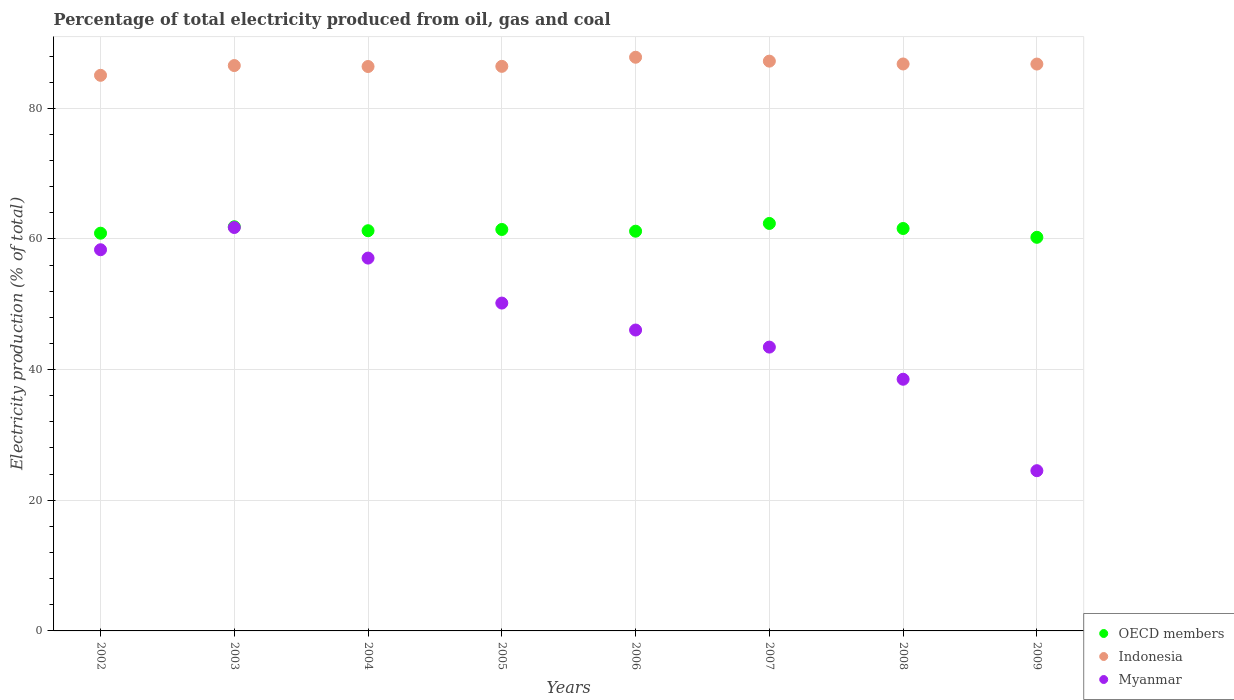Is the number of dotlines equal to the number of legend labels?
Offer a terse response. Yes. What is the electricity production in in OECD members in 2004?
Provide a short and direct response. 61.26. Across all years, what is the maximum electricity production in in Indonesia?
Keep it short and to the point. 87.81. Across all years, what is the minimum electricity production in in OECD members?
Make the answer very short. 60.25. In which year was the electricity production in in OECD members maximum?
Offer a very short reply. 2007. In which year was the electricity production in in Myanmar minimum?
Offer a terse response. 2009. What is the total electricity production in in Indonesia in the graph?
Offer a very short reply. 692.97. What is the difference between the electricity production in in Myanmar in 2004 and that in 2005?
Provide a short and direct response. 6.89. What is the difference between the electricity production in in Myanmar in 2004 and the electricity production in in Indonesia in 2007?
Your answer should be very brief. -30.15. What is the average electricity production in in OECD members per year?
Keep it short and to the point. 61.36. In the year 2009, what is the difference between the electricity production in in OECD members and electricity production in in Indonesia?
Give a very brief answer. -26.52. In how many years, is the electricity production in in Myanmar greater than 12 %?
Your response must be concise. 8. What is the ratio of the electricity production in in Indonesia in 2003 to that in 2008?
Provide a succinct answer. 1. Is the difference between the electricity production in in OECD members in 2005 and 2006 greater than the difference between the electricity production in in Indonesia in 2005 and 2006?
Offer a terse response. Yes. What is the difference between the highest and the second highest electricity production in in Myanmar?
Offer a very short reply. 3.4. What is the difference between the highest and the lowest electricity production in in Indonesia?
Offer a terse response. 2.76. Is it the case that in every year, the sum of the electricity production in in Indonesia and electricity production in in Myanmar  is greater than the electricity production in in OECD members?
Provide a short and direct response. Yes. Does the electricity production in in OECD members monotonically increase over the years?
Ensure brevity in your answer.  No. Is the electricity production in in Myanmar strictly greater than the electricity production in in Indonesia over the years?
Provide a succinct answer. No. How many dotlines are there?
Keep it short and to the point. 3. Does the graph contain grids?
Your answer should be compact. Yes. Where does the legend appear in the graph?
Provide a succinct answer. Bottom right. What is the title of the graph?
Your response must be concise. Percentage of total electricity produced from oil, gas and coal. Does "Burundi" appear as one of the legend labels in the graph?
Make the answer very short. No. What is the label or title of the X-axis?
Offer a terse response. Years. What is the label or title of the Y-axis?
Offer a terse response. Electricity production (% of total). What is the Electricity production (% of total) of OECD members in 2002?
Keep it short and to the point. 60.88. What is the Electricity production (% of total) in Indonesia in 2002?
Make the answer very short. 85.05. What is the Electricity production (% of total) of Myanmar in 2002?
Your answer should be very brief. 58.35. What is the Electricity production (% of total) in OECD members in 2003?
Offer a very short reply. 61.86. What is the Electricity production (% of total) in Indonesia in 2003?
Your answer should be very brief. 86.54. What is the Electricity production (% of total) of Myanmar in 2003?
Your response must be concise. 61.75. What is the Electricity production (% of total) of OECD members in 2004?
Give a very brief answer. 61.26. What is the Electricity production (% of total) in Indonesia in 2004?
Give a very brief answer. 86.39. What is the Electricity production (% of total) of Myanmar in 2004?
Make the answer very short. 57.07. What is the Electricity production (% of total) in OECD members in 2005?
Your answer should be very brief. 61.45. What is the Electricity production (% of total) of Indonesia in 2005?
Give a very brief answer. 86.42. What is the Electricity production (% of total) of Myanmar in 2005?
Your response must be concise. 50.18. What is the Electricity production (% of total) of OECD members in 2006?
Your response must be concise. 61.19. What is the Electricity production (% of total) of Indonesia in 2006?
Your answer should be very brief. 87.81. What is the Electricity production (% of total) in Myanmar in 2006?
Give a very brief answer. 46.06. What is the Electricity production (% of total) of OECD members in 2007?
Ensure brevity in your answer.  62.37. What is the Electricity production (% of total) in Indonesia in 2007?
Make the answer very short. 87.22. What is the Electricity production (% of total) of Myanmar in 2007?
Give a very brief answer. 43.44. What is the Electricity production (% of total) in OECD members in 2008?
Your answer should be very brief. 61.6. What is the Electricity production (% of total) of Indonesia in 2008?
Provide a succinct answer. 86.78. What is the Electricity production (% of total) in Myanmar in 2008?
Offer a very short reply. 38.52. What is the Electricity production (% of total) of OECD members in 2009?
Offer a terse response. 60.25. What is the Electricity production (% of total) in Indonesia in 2009?
Provide a short and direct response. 86.77. What is the Electricity production (% of total) in Myanmar in 2009?
Your response must be concise. 24.53. Across all years, what is the maximum Electricity production (% of total) of OECD members?
Provide a short and direct response. 62.37. Across all years, what is the maximum Electricity production (% of total) in Indonesia?
Provide a succinct answer. 87.81. Across all years, what is the maximum Electricity production (% of total) of Myanmar?
Offer a terse response. 61.75. Across all years, what is the minimum Electricity production (% of total) of OECD members?
Your answer should be very brief. 60.25. Across all years, what is the minimum Electricity production (% of total) of Indonesia?
Provide a short and direct response. 85.05. Across all years, what is the minimum Electricity production (% of total) of Myanmar?
Give a very brief answer. 24.53. What is the total Electricity production (% of total) of OECD members in the graph?
Make the answer very short. 490.85. What is the total Electricity production (% of total) of Indonesia in the graph?
Offer a very short reply. 692.97. What is the total Electricity production (% of total) of Myanmar in the graph?
Your response must be concise. 379.9. What is the difference between the Electricity production (% of total) in OECD members in 2002 and that in 2003?
Your response must be concise. -0.98. What is the difference between the Electricity production (% of total) of Indonesia in 2002 and that in 2003?
Your response must be concise. -1.49. What is the difference between the Electricity production (% of total) in Myanmar in 2002 and that in 2003?
Make the answer very short. -3.4. What is the difference between the Electricity production (% of total) in OECD members in 2002 and that in 2004?
Provide a short and direct response. -0.38. What is the difference between the Electricity production (% of total) in Indonesia in 2002 and that in 2004?
Your response must be concise. -1.35. What is the difference between the Electricity production (% of total) of Myanmar in 2002 and that in 2004?
Your answer should be very brief. 1.28. What is the difference between the Electricity production (% of total) of OECD members in 2002 and that in 2005?
Your response must be concise. -0.57. What is the difference between the Electricity production (% of total) of Indonesia in 2002 and that in 2005?
Provide a short and direct response. -1.37. What is the difference between the Electricity production (% of total) in Myanmar in 2002 and that in 2005?
Ensure brevity in your answer.  8.16. What is the difference between the Electricity production (% of total) of OECD members in 2002 and that in 2006?
Offer a very short reply. -0.31. What is the difference between the Electricity production (% of total) of Indonesia in 2002 and that in 2006?
Give a very brief answer. -2.76. What is the difference between the Electricity production (% of total) of Myanmar in 2002 and that in 2006?
Give a very brief answer. 12.29. What is the difference between the Electricity production (% of total) in OECD members in 2002 and that in 2007?
Offer a terse response. -1.49. What is the difference between the Electricity production (% of total) of Indonesia in 2002 and that in 2007?
Your answer should be compact. -2.17. What is the difference between the Electricity production (% of total) in Myanmar in 2002 and that in 2007?
Your response must be concise. 14.9. What is the difference between the Electricity production (% of total) of OECD members in 2002 and that in 2008?
Provide a short and direct response. -0.72. What is the difference between the Electricity production (% of total) of Indonesia in 2002 and that in 2008?
Offer a terse response. -1.73. What is the difference between the Electricity production (% of total) in Myanmar in 2002 and that in 2008?
Provide a short and direct response. 19.82. What is the difference between the Electricity production (% of total) of OECD members in 2002 and that in 2009?
Make the answer very short. 0.63. What is the difference between the Electricity production (% of total) in Indonesia in 2002 and that in 2009?
Ensure brevity in your answer.  -1.72. What is the difference between the Electricity production (% of total) in Myanmar in 2002 and that in 2009?
Make the answer very short. 33.82. What is the difference between the Electricity production (% of total) in OECD members in 2003 and that in 2004?
Offer a terse response. 0.61. What is the difference between the Electricity production (% of total) of Indonesia in 2003 and that in 2004?
Offer a very short reply. 0.15. What is the difference between the Electricity production (% of total) in Myanmar in 2003 and that in 2004?
Offer a very short reply. 4.68. What is the difference between the Electricity production (% of total) of OECD members in 2003 and that in 2005?
Keep it short and to the point. 0.41. What is the difference between the Electricity production (% of total) of Indonesia in 2003 and that in 2005?
Provide a succinct answer. 0.12. What is the difference between the Electricity production (% of total) in Myanmar in 2003 and that in 2005?
Offer a terse response. 11.57. What is the difference between the Electricity production (% of total) in OECD members in 2003 and that in 2006?
Offer a very short reply. 0.68. What is the difference between the Electricity production (% of total) of Indonesia in 2003 and that in 2006?
Give a very brief answer. -1.27. What is the difference between the Electricity production (% of total) of Myanmar in 2003 and that in 2006?
Your response must be concise. 15.69. What is the difference between the Electricity production (% of total) in OECD members in 2003 and that in 2007?
Your response must be concise. -0.51. What is the difference between the Electricity production (% of total) in Indonesia in 2003 and that in 2007?
Your answer should be compact. -0.68. What is the difference between the Electricity production (% of total) in Myanmar in 2003 and that in 2007?
Offer a very short reply. 18.31. What is the difference between the Electricity production (% of total) of OECD members in 2003 and that in 2008?
Your answer should be very brief. 0.27. What is the difference between the Electricity production (% of total) in Indonesia in 2003 and that in 2008?
Your answer should be compact. -0.24. What is the difference between the Electricity production (% of total) of Myanmar in 2003 and that in 2008?
Your answer should be very brief. 23.23. What is the difference between the Electricity production (% of total) in OECD members in 2003 and that in 2009?
Provide a short and direct response. 1.61. What is the difference between the Electricity production (% of total) of Indonesia in 2003 and that in 2009?
Give a very brief answer. -0.23. What is the difference between the Electricity production (% of total) of Myanmar in 2003 and that in 2009?
Your response must be concise. 37.23. What is the difference between the Electricity production (% of total) in OECD members in 2004 and that in 2005?
Ensure brevity in your answer.  -0.19. What is the difference between the Electricity production (% of total) in Indonesia in 2004 and that in 2005?
Your response must be concise. -0.02. What is the difference between the Electricity production (% of total) in Myanmar in 2004 and that in 2005?
Your answer should be compact. 6.89. What is the difference between the Electricity production (% of total) of OECD members in 2004 and that in 2006?
Give a very brief answer. 0.07. What is the difference between the Electricity production (% of total) in Indonesia in 2004 and that in 2006?
Make the answer very short. -1.42. What is the difference between the Electricity production (% of total) in Myanmar in 2004 and that in 2006?
Give a very brief answer. 11.01. What is the difference between the Electricity production (% of total) of OECD members in 2004 and that in 2007?
Your response must be concise. -1.11. What is the difference between the Electricity production (% of total) of Indonesia in 2004 and that in 2007?
Your response must be concise. -0.82. What is the difference between the Electricity production (% of total) in Myanmar in 2004 and that in 2007?
Your response must be concise. 13.62. What is the difference between the Electricity production (% of total) in OECD members in 2004 and that in 2008?
Make the answer very short. -0.34. What is the difference between the Electricity production (% of total) of Indonesia in 2004 and that in 2008?
Your answer should be compact. -0.39. What is the difference between the Electricity production (% of total) of Myanmar in 2004 and that in 2008?
Your answer should be compact. 18.55. What is the difference between the Electricity production (% of total) in OECD members in 2004 and that in 2009?
Your response must be concise. 1.01. What is the difference between the Electricity production (% of total) of Indonesia in 2004 and that in 2009?
Provide a succinct answer. -0.38. What is the difference between the Electricity production (% of total) of Myanmar in 2004 and that in 2009?
Give a very brief answer. 32.54. What is the difference between the Electricity production (% of total) in OECD members in 2005 and that in 2006?
Make the answer very short. 0.26. What is the difference between the Electricity production (% of total) of Indonesia in 2005 and that in 2006?
Provide a succinct answer. -1.39. What is the difference between the Electricity production (% of total) in Myanmar in 2005 and that in 2006?
Offer a terse response. 4.13. What is the difference between the Electricity production (% of total) of OECD members in 2005 and that in 2007?
Your answer should be very brief. -0.92. What is the difference between the Electricity production (% of total) in Indonesia in 2005 and that in 2007?
Provide a short and direct response. -0.8. What is the difference between the Electricity production (% of total) in Myanmar in 2005 and that in 2007?
Provide a short and direct response. 6.74. What is the difference between the Electricity production (% of total) of OECD members in 2005 and that in 2008?
Your response must be concise. -0.15. What is the difference between the Electricity production (% of total) in Indonesia in 2005 and that in 2008?
Your answer should be compact. -0.36. What is the difference between the Electricity production (% of total) in Myanmar in 2005 and that in 2008?
Your answer should be very brief. 11.66. What is the difference between the Electricity production (% of total) in OECD members in 2005 and that in 2009?
Give a very brief answer. 1.2. What is the difference between the Electricity production (% of total) in Indonesia in 2005 and that in 2009?
Provide a succinct answer. -0.35. What is the difference between the Electricity production (% of total) in Myanmar in 2005 and that in 2009?
Your response must be concise. 25.66. What is the difference between the Electricity production (% of total) of OECD members in 2006 and that in 2007?
Your response must be concise. -1.19. What is the difference between the Electricity production (% of total) in Indonesia in 2006 and that in 2007?
Keep it short and to the point. 0.6. What is the difference between the Electricity production (% of total) in Myanmar in 2006 and that in 2007?
Provide a succinct answer. 2.61. What is the difference between the Electricity production (% of total) of OECD members in 2006 and that in 2008?
Ensure brevity in your answer.  -0.41. What is the difference between the Electricity production (% of total) of Indonesia in 2006 and that in 2008?
Offer a very short reply. 1.03. What is the difference between the Electricity production (% of total) in Myanmar in 2006 and that in 2008?
Your response must be concise. 7.53. What is the difference between the Electricity production (% of total) in OECD members in 2006 and that in 2009?
Keep it short and to the point. 0.94. What is the difference between the Electricity production (% of total) in Indonesia in 2006 and that in 2009?
Provide a succinct answer. 1.04. What is the difference between the Electricity production (% of total) of Myanmar in 2006 and that in 2009?
Your answer should be very brief. 21.53. What is the difference between the Electricity production (% of total) of OECD members in 2007 and that in 2008?
Your answer should be very brief. 0.77. What is the difference between the Electricity production (% of total) in Indonesia in 2007 and that in 2008?
Make the answer very short. 0.43. What is the difference between the Electricity production (% of total) of Myanmar in 2007 and that in 2008?
Ensure brevity in your answer.  4.92. What is the difference between the Electricity production (% of total) of OECD members in 2007 and that in 2009?
Ensure brevity in your answer.  2.12. What is the difference between the Electricity production (% of total) in Indonesia in 2007 and that in 2009?
Your answer should be compact. 0.45. What is the difference between the Electricity production (% of total) in Myanmar in 2007 and that in 2009?
Keep it short and to the point. 18.92. What is the difference between the Electricity production (% of total) in OECD members in 2008 and that in 2009?
Ensure brevity in your answer.  1.35. What is the difference between the Electricity production (% of total) of Indonesia in 2008 and that in 2009?
Your answer should be very brief. 0.01. What is the difference between the Electricity production (% of total) of Myanmar in 2008 and that in 2009?
Ensure brevity in your answer.  14. What is the difference between the Electricity production (% of total) in OECD members in 2002 and the Electricity production (% of total) in Indonesia in 2003?
Your answer should be compact. -25.66. What is the difference between the Electricity production (% of total) in OECD members in 2002 and the Electricity production (% of total) in Myanmar in 2003?
Provide a short and direct response. -0.87. What is the difference between the Electricity production (% of total) in Indonesia in 2002 and the Electricity production (% of total) in Myanmar in 2003?
Your answer should be very brief. 23.3. What is the difference between the Electricity production (% of total) of OECD members in 2002 and the Electricity production (% of total) of Indonesia in 2004?
Keep it short and to the point. -25.51. What is the difference between the Electricity production (% of total) of OECD members in 2002 and the Electricity production (% of total) of Myanmar in 2004?
Make the answer very short. 3.81. What is the difference between the Electricity production (% of total) of Indonesia in 2002 and the Electricity production (% of total) of Myanmar in 2004?
Your response must be concise. 27.98. What is the difference between the Electricity production (% of total) in OECD members in 2002 and the Electricity production (% of total) in Indonesia in 2005?
Your answer should be compact. -25.54. What is the difference between the Electricity production (% of total) in OECD members in 2002 and the Electricity production (% of total) in Myanmar in 2005?
Provide a short and direct response. 10.7. What is the difference between the Electricity production (% of total) in Indonesia in 2002 and the Electricity production (% of total) in Myanmar in 2005?
Provide a succinct answer. 34.86. What is the difference between the Electricity production (% of total) in OECD members in 2002 and the Electricity production (% of total) in Indonesia in 2006?
Your response must be concise. -26.93. What is the difference between the Electricity production (% of total) of OECD members in 2002 and the Electricity production (% of total) of Myanmar in 2006?
Your response must be concise. 14.82. What is the difference between the Electricity production (% of total) of Indonesia in 2002 and the Electricity production (% of total) of Myanmar in 2006?
Your answer should be compact. 38.99. What is the difference between the Electricity production (% of total) of OECD members in 2002 and the Electricity production (% of total) of Indonesia in 2007?
Offer a terse response. -26.34. What is the difference between the Electricity production (% of total) in OECD members in 2002 and the Electricity production (% of total) in Myanmar in 2007?
Provide a short and direct response. 17.43. What is the difference between the Electricity production (% of total) in Indonesia in 2002 and the Electricity production (% of total) in Myanmar in 2007?
Offer a very short reply. 41.6. What is the difference between the Electricity production (% of total) of OECD members in 2002 and the Electricity production (% of total) of Indonesia in 2008?
Ensure brevity in your answer.  -25.9. What is the difference between the Electricity production (% of total) in OECD members in 2002 and the Electricity production (% of total) in Myanmar in 2008?
Offer a terse response. 22.36. What is the difference between the Electricity production (% of total) in Indonesia in 2002 and the Electricity production (% of total) in Myanmar in 2008?
Provide a succinct answer. 46.52. What is the difference between the Electricity production (% of total) in OECD members in 2002 and the Electricity production (% of total) in Indonesia in 2009?
Give a very brief answer. -25.89. What is the difference between the Electricity production (% of total) in OECD members in 2002 and the Electricity production (% of total) in Myanmar in 2009?
Keep it short and to the point. 36.35. What is the difference between the Electricity production (% of total) in Indonesia in 2002 and the Electricity production (% of total) in Myanmar in 2009?
Make the answer very short. 60.52. What is the difference between the Electricity production (% of total) in OECD members in 2003 and the Electricity production (% of total) in Indonesia in 2004?
Your response must be concise. -24.53. What is the difference between the Electricity production (% of total) in OECD members in 2003 and the Electricity production (% of total) in Myanmar in 2004?
Ensure brevity in your answer.  4.79. What is the difference between the Electricity production (% of total) of Indonesia in 2003 and the Electricity production (% of total) of Myanmar in 2004?
Keep it short and to the point. 29.47. What is the difference between the Electricity production (% of total) in OECD members in 2003 and the Electricity production (% of total) in Indonesia in 2005?
Provide a short and direct response. -24.55. What is the difference between the Electricity production (% of total) in OECD members in 2003 and the Electricity production (% of total) in Myanmar in 2005?
Make the answer very short. 11.68. What is the difference between the Electricity production (% of total) of Indonesia in 2003 and the Electricity production (% of total) of Myanmar in 2005?
Ensure brevity in your answer.  36.36. What is the difference between the Electricity production (% of total) of OECD members in 2003 and the Electricity production (% of total) of Indonesia in 2006?
Offer a very short reply. -25.95. What is the difference between the Electricity production (% of total) in OECD members in 2003 and the Electricity production (% of total) in Myanmar in 2006?
Your answer should be compact. 15.81. What is the difference between the Electricity production (% of total) of Indonesia in 2003 and the Electricity production (% of total) of Myanmar in 2006?
Your response must be concise. 40.48. What is the difference between the Electricity production (% of total) in OECD members in 2003 and the Electricity production (% of total) in Indonesia in 2007?
Ensure brevity in your answer.  -25.35. What is the difference between the Electricity production (% of total) of OECD members in 2003 and the Electricity production (% of total) of Myanmar in 2007?
Provide a short and direct response. 18.42. What is the difference between the Electricity production (% of total) in Indonesia in 2003 and the Electricity production (% of total) in Myanmar in 2007?
Your answer should be very brief. 43.09. What is the difference between the Electricity production (% of total) of OECD members in 2003 and the Electricity production (% of total) of Indonesia in 2008?
Your response must be concise. -24.92. What is the difference between the Electricity production (% of total) of OECD members in 2003 and the Electricity production (% of total) of Myanmar in 2008?
Your response must be concise. 23.34. What is the difference between the Electricity production (% of total) of Indonesia in 2003 and the Electricity production (% of total) of Myanmar in 2008?
Offer a very short reply. 48.02. What is the difference between the Electricity production (% of total) of OECD members in 2003 and the Electricity production (% of total) of Indonesia in 2009?
Provide a short and direct response. -24.91. What is the difference between the Electricity production (% of total) in OECD members in 2003 and the Electricity production (% of total) in Myanmar in 2009?
Your answer should be compact. 37.34. What is the difference between the Electricity production (% of total) in Indonesia in 2003 and the Electricity production (% of total) in Myanmar in 2009?
Your response must be concise. 62.01. What is the difference between the Electricity production (% of total) of OECD members in 2004 and the Electricity production (% of total) of Indonesia in 2005?
Your answer should be very brief. -25.16. What is the difference between the Electricity production (% of total) in OECD members in 2004 and the Electricity production (% of total) in Myanmar in 2005?
Provide a succinct answer. 11.07. What is the difference between the Electricity production (% of total) in Indonesia in 2004 and the Electricity production (% of total) in Myanmar in 2005?
Your response must be concise. 36.21. What is the difference between the Electricity production (% of total) in OECD members in 2004 and the Electricity production (% of total) in Indonesia in 2006?
Keep it short and to the point. -26.55. What is the difference between the Electricity production (% of total) in OECD members in 2004 and the Electricity production (% of total) in Myanmar in 2006?
Provide a short and direct response. 15.2. What is the difference between the Electricity production (% of total) of Indonesia in 2004 and the Electricity production (% of total) of Myanmar in 2006?
Provide a succinct answer. 40.34. What is the difference between the Electricity production (% of total) of OECD members in 2004 and the Electricity production (% of total) of Indonesia in 2007?
Your answer should be very brief. -25.96. What is the difference between the Electricity production (% of total) of OECD members in 2004 and the Electricity production (% of total) of Myanmar in 2007?
Your answer should be compact. 17.81. What is the difference between the Electricity production (% of total) in Indonesia in 2004 and the Electricity production (% of total) in Myanmar in 2007?
Give a very brief answer. 42.95. What is the difference between the Electricity production (% of total) of OECD members in 2004 and the Electricity production (% of total) of Indonesia in 2008?
Your answer should be compact. -25.52. What is the difference between the Electricity production (% of total) in OECD members in 2004 and the Electricity production (% of total) in Myanmar in 2008?
Your answer should be compact. 22.73. What is the difference between the Electricity production (% of total) of Indonesia in 2004 and the Electricity production (% of total) of Myanmar in 2008?
Provide a short and direct response. 47.87. What is the difference between the Electricity production (% of total) in OECD members in 2004 and the Electricity production (% of total) in Indonesia in 2009?
Offer a terse response. -25.51. What is the difference between the Electricity production (% of total) in OECD members in 2004 and the Electricity production (% of total) in Myanmar in 2009?
Make the answer very short. 36.73. What is the difference between the Electricity production (% of total) in Indonesia in 2004 and the Electricity production (% of total) in Myanmar in 2009?
Provide a succinct answer. 61.87. What is the difference between the Electricity production (% of total) of OECD members in 2005 and the Electricity production (% of total) of Indonesia in 2006?
Your answer should be very brief. -26.36. What is the difference between the Electricity production (% of total) of OECD members in 2005 and the Electricity production (% of total) of Myanmar in 2006?
Keep it short and to the point. 15.39. What is the difference between the Electricity production (% of total) in Indonesia in 2005 and the Electricity production (% of total) in Myanmar in 2006?
Your answer should be compact. 40.36. What is the difference between the Electricity production (% of total) of OECD members in 2005 and the Electricity production (% of total) of Indonesia in 2007?
Your answer should be very brief. -25.77. What is the difference between the Electricity production (% of total) in OECD members in 2005 and the Electricity production (% of total) in Myanmar in 2007?
Give a very brief answer. 18. What is the difference between the Electricity production (% of total) of Indonesia in 2005 and the Electricity production (% of total) of Myanmar in 2007?
Provide a short and direct response. 42.97. What is the difference between the Electricity production (% of total) of OECD members in 2005 and the Electricity production (% of total) of Indonesia in 2008?
Make the answer very short. -25.33. What is the difference between the Electricity production (% of total) of OECD members in 2005 and the Electricity production (% of total) of Myanmar in 2008?
Give a very brief answer. 22.93. What is the difference between the Electricity production (% of total) in Indonesia in 2005 and the Electricity production (% of total) in Myanmar in 2008?
Your response must be concise. 47.89. What is the difference between the Electricity production (% of total) in OECD members in 2005 and the Electricity production (% of total) in Indonesia in 2009?
Your answer should be very brief. -25.32. What is the difference between the Electricity production (% of total) of OECD members in 2005 and the Electricity production (% of total) of Myanmar in 2009?
Offer a very short reply. 36.92. What is the difference between the Electricity production (% of total) in Indonesia in 2005 and the Electricity production (% of total) in Myanmar in 2009?
Ensure brevity in your answer.  61.89. What is the difference between the Electricity production (% of total) in OECD members in 2006 and the Electricity production (% of total) in Indonesia in 2007?
Your answer should be very brief. -26.03. What is the difference between the Electricity production (% of total) in OECD members in 2006 and the Electricity production (% of total) in Myanmar in 2007?
Make the answer very short. 17.74. What is the difference between the Electricity production (% of total) in Indonesia in 2006 and the Electricity production (% of total) in Myanmar in 2007?
Your answer should be very brief. 44.37. What is the difference between the Electricity production (% of total) of OECD members in 2006 and the Electricity production (% of total) of Indonesia in 2008?
Give a very brief answer. -25.6. What is the difference between the Electricity production (% of total) of OECD members in 2006 and the Electricity production (% of total) of Myanmar in 2008?
Make the answer very short. 22.66. What is the difference between the Electricity production (% of total) in Indonesia in 2006 and the Electricity production (% of total) in Myanmar in 2008?
Make the answer very short. 49.29. What is the difference between the Electricity production (% of total) of OECD members in 2006 and the Electricity production (% of total) of Indonesia in 2009?
Your answer should be very brief. -25.58. What is the difference between the Electricity production (% of total) of OECD members in 2006 and the Electricity production (% of total) of Myanmar in 2009?
Your answer should be compact. 36.66. What is the difference between the Electricity production (% of total) in Indonesia in 2006 and the Electricity production (% of total) in Myanmar in 2009?
Provide a short and direct response. 63.29. What is the difference between the Electricity production (% of total) in OECD members in 2007 and the Electricity production (% of total) in Indonesia in 2008?
Your answer should be very brief. -24.41. What is the difference between the Electricity production (% of total) of OECD members in 2007 and the Electricity production (% of total) of Myanmar in 2008?
Your answer should be compact. 23.85. What is the difference between the Electricity production (% of total) of Indonesia in 2007 and the Electricity production (% of total) of Myanmar in 2008?
Your answer should be very brief. 48.69. What is the difference between the Electricity production (% of total) in OECD members in 2007 and the Electricity production (% of total) in Indonesia in 2009?
Provide a succinct answer. -24.4. What is the difference between the Electricity production (% of total) in OECD members in 2007 and the Electricity production (% of total) in Myanmar in 2009?
Keep it short and to the point. 37.85. What is the difference between the Electricity production (% of total) of Indonesia in 2007 and the Electricity production (% of total) of Myanmar in 2009?
Offer a terse response. 62.69. What is the difference between the Electricity production (% of total) in OECD members in 2008 and the Electricity production (% of total) in Indonesia in 2009?
Your answer should be very brief. -25.17. What is the difference between the Electricity production (% of total) in OECD members in 2008 and the Electricity production (% of total) in Myanmar in 2009?
Ensure brevity in your answer.  37.07. What is the difference between the Electricity production (% of total) in Indonesia in 2008 and the Electricity production (% of total) in Myanmar in 2009?
Your answer should be very brief. 62.26. What is the average Electricity production (% of total) in OECD members per year?
Ensure brevity in your answer.  61.36. What is the average Electricity production (% of total) of Indonesia per year?
Offer a terse response. 86.62. What is the average Electricity production (% of total) of Myanmar per year?
Your answer should be compact. 47.49. In the year 2002, what is the difference between the Electricity production (% of total) in OECD members and Electricity production (% of total) in Indonesia?
Provide a short and direct response. -24.17. In the year 2002, what is the difference between the Electricity production (% of total) in OECD members and Electricity production (% of total) in Myanmar?
Offer a terse response. 2.53. In the year 2002, what is the difference between the Electricity production (% of total) in Indonesia and Electricity production (% of total) in Myanmar?
Offer a very short reply. 26.7. In the year 2003, what is the difference between the Electricity production (% of total) in OECD members and Electricity production (% of total) in Indonesia?
Your response must be concise. -24.68. In the year 2003, what is the difference between the Electricity production (% of total) of OECD members and Electricity production (% of total) of Myanmar?
Your answer should be compact. 0.11. In the year 2003, what is the difference between the Electricity production (% of total) of Indonesia and Electricity production (% of total) of Myanmar?
Keep it short and to the point. 24.79. In the year 2004, what is the difference between the Electricity production (% of total) in OECD members and Electricity production (% of total) in Indonesia?
Offer a terse response. -25.14. In the year 2004, what is the difference between the Electricity production (% of total) of OECD members and Electricity production (% of total) of Myanmar?
Give a very brief answer. 4.19. In the year 2004, what is the difference between the Electricity production (% of total) in Indonesia and Electricity production (% of total) in Myanmar?
Your response must be concise. 29.32. In the year 2005, what is the difference between the Electricity production (% of total) of OECD members and Electricity production (% of total) of Indonesia?
Provide a succinct answer. -24.97. In the year 2005, what is the difference between the Electricity production (% of total) in OECD members and Electricity production (% of total) in Myanmar?
Your response must be concise. 11.27. In the year 2005, what is the difference between the Electricity production (% of total) in Indonesia and Electricity production (% of total) in Myanmar?
Your response must be concise. 36.23. In the year 2006, what is the difference between the Electricity production (% of total) of OECD members and Electricity production (% of total) of Indonesia?
Make the answer very short. -26.63. In the year 2006, what is the difference between the Electricity production (% of total) of OECD members and Electricity production (% of total) of Myanmar?
Ensure brevity in your answer.  15.13. In the year 2006, what is the difference between the Electricity production (% of total) of Indonesia and Electricity production (% of total) of Myanmar?
Keep it short and to the point. 41.75. In the year 2007, what is the difference between the Electricity production (% of total) in OECD members and Electricity production (% of total) in Indonesia?
Your answer should be very brief. -24.84. In the year 2007, what is the difference between the Electricity production (% of total) in OECD members and Electricity production (% of total) in Myanmar?
Your answer should be compact. 18.93. In the year 2007, what is the difference between the Electricity production (% of total) of Indonesia and Electricity production (% of total) of Myanmar?
Your answer should be very brief. 43.77. In the year 2008, what is the difference between the Electricity production (% of total) in OECD members and Electricity production (% of total) in Indonesia?
Your answer should be compact. -25.18. In the year 2008, what is the difference between the Electricity production (% of total) of OECD members and Electricity production (% of total) of Myanmar?
Your response must be concise. 23.08. In the year 2008, what is the difference between the Electricity production (% of total) of Indonesia and Electricity production (% of total) of Myanmar?
Offer a very short reply. 48.26. In the year 2009, what is the difference between the Electricity production (% of total) of OECD members and Electricity production (% of total) of Indonesia?
Offer a very short reply. -26.52. In the year 2009, what is the difference between the Electricity production (% of total) of OECD members and Electricity production (% of total) of Myanmar?
Offer a very short reply. 35.72. In the year 2009, what is the difference between the Electricity production (% of total) in Indonesia and Electricity production (% of total) in Myanmar?
Offer a very short reply. 62.24. What is the ratio of the Electricity production (% of total) of OECD members in 2002 to that in 2003?
Provide a succinct answer. 0.98. What is the ratio of the Electricity production (% of total) of Indonesia in 2002 to that in 2003?
Offer a very short reply. 0.98. What is the ratio of the Electricity production (% of total) in Myanmar in 2002 to that in 2003?
Provide a succinct answer. 0.94. What is the ratio of the Electricity production (% of total) in OECD members in 2002 to that in 2004?
Your answer should be very brief. 0.99. What is the ratio of the Electricity production (% of total) of Indonesia in 2002 to that in 2004?
Offer a terse response. 0.98. What is the ratio of the Electricity production (% of total) of Myanmar in 2002 to that in 2004?
Give a very brief answer. 1.02. What is the ratio of the Electricity production (% of total) of OECD members in 2002 to that in 2005?
Ensure brevity in your answer.  0.99. What is the ratio of the Electricity production (% of total) of Indonesia in 2002 to that in 2005?
Keep it short and to the point. 0.98. What is the ratio of the Electricity production (% of total) of Myanmar in 2002 to that in 2005?
Give a very brief answer. 1.16. What is the ratio of the Electricity production (% of total) in OECD members in 2002 to that in 2006?
Offer a very short reply. 0.99. What is the ratio of the Electricity production (% of total) in Indonesia in 2002 to that in 2006?
Offer a very short reply. 0.97. What is the ratio of the Electricity production (% of total) in Myanmar in 2002 to that in 2006?
Ensure brevity in your answer.  1.27. What is the ratio of the Electricity production (% of total) in OECD members in 2002 to that in 2007?
Ensure brevity in your answer.  0.98. What is the ratio of the Electricity production (% of total) in Indonesia in 2002 to that in 2007?
Provide a succinct answer. 0.98. What is the ratio of the Electricity production (% of total) in Myanmar in 2002 to that in 2007?
Offer a very short reply. 1.34. What is the ratio of the Electricity production (% of total) of OECD members in 2002 to that in 2008?
Provide a succinct answer. 0.99. What is the ratio of the Electricity production (% of total) in Myanmar in 2002 to that in 2008?
Provide a succinct answer. 1.51. What is the ratio of the Electricity production (% of total) in OECD members in 2002 to that in 2009?
Provide a short and direct response. 1.01. What is the ratio of the Electricity production (% of total) of Indonesia in 2002 to that in 2009?
Offer a terse response. 0.98. What is the ratio of the Electricity production (% of total) of Myanmar in 2002 to that in 2009?
Provide a succinct answer. 2.38. What is the ratio of the Electricity production (% of total) in OECD members in 2003 to that in 2004?
Provide a succinct answer. 1.01. What is the ratio of the Electricity production (% of total) in Indonesia in 2003 to that in 2004?
Give a very brief answer. 1. What is the ratio of the Electricity production (% of total) in Myanmar in 2003 to that in 2004?
Provide a succinct answer. 1.08. What is the ratio of the Electricity production (% of total) of OECD members in 2003 to that in 2005?
Offer a terse response. 1.01. What is the ratio of the Electricity production (% of total) of Indonesia in 2003 to that in 2005?
Provide a short and direct response. 1. What is the ratio of the Electricity production (% of total) in Myanmar in 2003 to that in 2005?
Give a very brief answer. 1.23. What is the ratio of the Electricity production (% of total) of OECD members in 2003 to that in 2006?
Keep it short and to the point. 1.01. What is the ratio of the Electricity production (% of total) of Indonesia in 2003 to that in 2006?
Give a very brief answer. 0.99. What is the ratio of the Electricity production (% of total) in Myanmar in 2003 to that in 2006?
Your response must be concise. 1.34. What is the ratio of the Electricity production (% of total) in Indonesia in 2003 to that in 2007?
Provide a short and direct response. 0.99. What is the ratio of the Electricity production (% of total) in Myanmar in 2003 to that in 2007?
Provide a short and direct response. 1.42. What is the ratio of the Electricity production (% of total) in Myanmar in 2003 to that in 2008?
Make the answer very short. 1.6. What is the ratio of the Electricity production (% of total) of OECD members in 2003 to that in 2009?
Give a very brief answer. 1.03. What is the ratio of the Electricity production (% of total) of Myanmar in 2003 to that in 2009?
Your answer should be very brief. 2.52. What is the ratio of the Electricity production (% of total) of OECD members in 2004 to that in 2005?
Ensure brevity in your answer.  1. What is the ratio of the Electricity production (% of total) of Myanmar in 2004 to that in 2005?
Ensure brevity in your answer.  1.14. What is the ratio of the Electricity production (% of total) in Indonesia in 2004 to that in 2006?
Ensure brevity in your answer.  0.98. What is the ratio of the Electricity production (% of total) of Myanmar in 2004 to that in 2006?
Give a very brief answer. 1.24. What is the ratio of the Electricity production (% of total) in OECD members in 2004 to that in 2007?
Make the answer very short. 0.98. What is the ratio of the Electricity production (% of total) in Indonesia in 2004 to that in 2007?
Your answer should be compact. 0.99. What is the ratio of the Electricity production (% of total) in Myanmar in 2004 to that in 2007?
Your answer should be very brief. 1.31. What is the ratio of the Electricity production (% of total) of Indonesia in 2004 to that in 2008?
Ensure brevity in your answer.  1. What is the ratio of the Electricity production (% of total) in Myanmar in 2004 to that in 2008?
Ensure brevity in your answer.  1.48. What is the ratio of the Electricity production (% of total) in OECD members in 2004 to that in 2009?
Offer a terse response. 1.02. What is the ratio of the Electricity production (% of total) in Indonesia in 2004 to that in 2009?
Offer a terse response. 1. What is the ratio of the Electricity production (% of total) of Myanmar in 2004 to that in 2009?
Keep it short and to the point. 2.33. What is the ratio of the Electricity production (% of total) of OECD members in 2005 to that in 2006?
Make the answer very short. 1. What is the ratio of the Electricity production (% of total) in Indonesia in 2005 to that in 2006?
Keep it short and to the point. 0.98. What is the ratio of the Electricity production (% of total) of Myanmar in 2005 to that in 2006?
Make the answer very short. 1.09. What is the ratio of the Electricity production (% of total) in OECD members in 2005 to that in 2007?
Provide a succinct answer. 0.99. What is the ratio of the Electricity production (% of total) in Indonesia in 2005 to that in 2007?
Offer a very short reply. 0.99. What is the ratio of the Electricity production (% of total) in Myanmar in 2005 to that in 2007?
Your answer should be compact. 1.16. What is the ratio of the Electricity production (% of total) of OECD members in 2005 to that in 2008?
Your answer should be very brief. 1. What is the ratio of the Electricity production (% of total) in Indonesia in 2005 to that in 2008?
Keep it short and to the point. 1. What is the ratio of the Electricity production (% of total) of Myanmar in 2005 to that in 2008?
Ensure brevity in your answer.  1.3. What is the ratio of the Electricity production (% of total) of OECD members in 2005 to that in 2009?
Your answer should be very brief. 1.02. What is the ratio of the Electricity production (% of total) of Indonesia in 2005 to that in 2009?
Make the answer very short. 1. What is the ratio of the Electricity production (% of total) of Myanmar in 2005 to that in 2009?
Make the answer very short. 2.05. What is the ratio of the Electricity production (% of total) of Indonesia in 2006 to that in 2007?
Make the answer very short. 1.01. What is the ratio of the Electricity production (% of total) of Myanmar in 2006 to that in 2007?
Your response must be concise. 1.06. What is the ratio of the Electricity production (% of total) of OECD members in 2006 to that in 2008?
Offer a terse response. 0.99. What is the ratio of the Electricity production (% of total) of Indonesia in 2006 to that in 2008?
Give a very brief answer. 1.01. What is the ratio of the Electricity production (% of total) of Myanmar in 2006 to that in 2008?
Provide a short and direct response. 1.2. What is the ratio of the Electricity production (% of total) in OECD members in 2006 to that in 2009?
Your answer should be compact. 1.02. What is the ratio of the Electricity production (% of total) in Myanmar in 2006 to that in 2009?
Offer a terse response. 1.88. What is the ratio of the Electricity production (% of total) in OECD members in 2007 to that in 2008?
Offer a very short reply. 1.01. What is the ratio of the Electricity production (% of total) of Myanmar in 2007 to that in 2008?
Your response must be concise. 1.13. What is the ratio of the Electricity production (% of total) in OECD members in 2007 to that in 2009?
Make the answer very short. 1.04. What is the ratio of the Electricity production (% of total) of Indonesia in 2007 to that in 2009?
Make the answer very short. 1.01. What is the ratio of the Electricity production (% of total) of Myanmar in 2007 to that in 2009?
Your answer should be compact. 1.77. What is the ratio of the Electricity production (% of total) in OECD members in 2008 to that in 2009?
Offer a very short reply. 1.02. What is the ratio of the Electricity production (% of total) of Myanmar in 2008 to that in 2009?
Keep it short and to the point. 1.57. What is the difference between the highest and the second highest Electricity production (% of total) in OECD members?
Offer a terse response. 0.51. What is the difference between the highest and the second highest Electricity production (% of total) in Indonesia?
Ensure brevity in your answer.  0.6. What is the difference between the highest and the second highest Electricity production (% of total) in Myanmar?
Provide a succinct answer. 3.4. What is the difference between the highest and the lowest Electricity production (% of total) in OECD members?
Offer a terse response. 2.12. What is the difference between the highest and the lowest Electricity production (% of total) of Indonesia?
Offer a very short reply. 2.76. What is the difference between the highest and the lowest Electricity production (% of total) in Myanmar?
Ensure brevity in your answer.  37.23. 